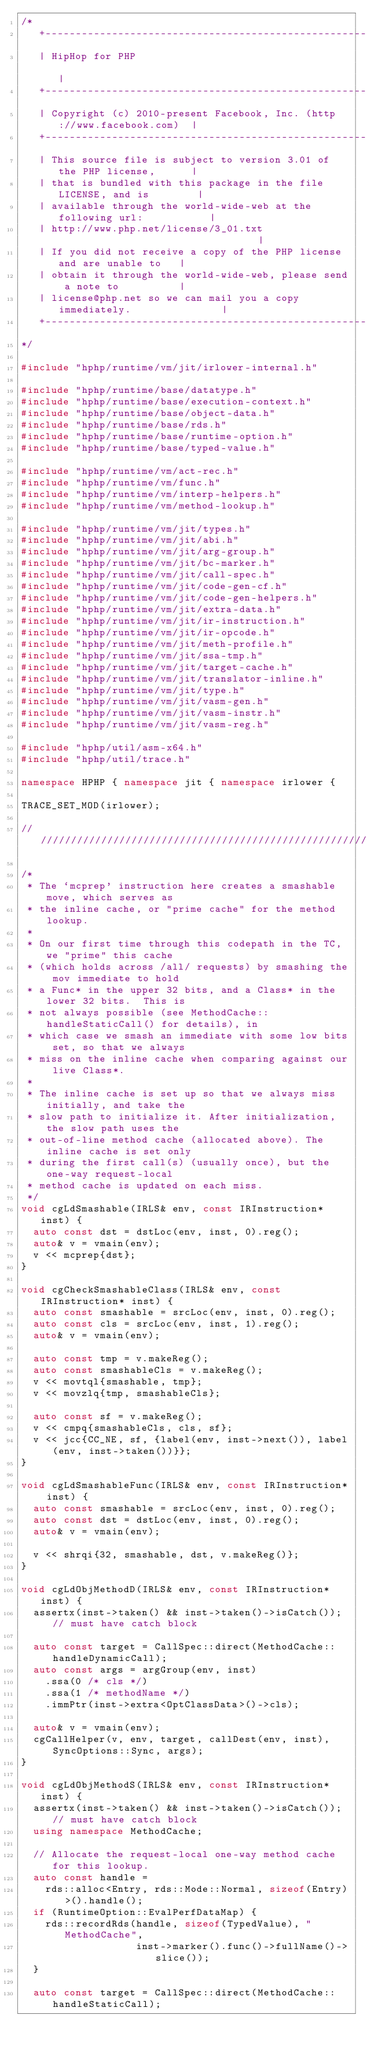<code> <loc_0><loc_0><loc_500><loc_500><_C++_>/*
   +----------------------------------------------------------------------+
   | HipHop for PHP                                                       |
   +----------------------------------------------------------------------+
   | Copyright (c) 2010-present Facebook, Inc. (http://www.facebook.com)  |
   +----------------------------------------------------------------------+
   | This source file is subject to version 3.01 of the PHP license,      |
   | that is bundled with this package in the file LICENSE, and is        |
   | available through the world-wide-web at the following url:           |
   | http://www.php.net/license/3_01.txt                                  |
   | If you did not receive a copy of the PHP license and are unable to   |
   | obtain it through the world-wide-web, please send a note to          |
   | license@php.net so we can mail you a copy immediately.               |
   +----------------------------------------------------------------------+
*/

#include "hphp/runtime/vm/jit/irlower-internal.h"

#include "hphp/runtime/base/datatype.h"
#include "hphp/runtime/base/execution-context.h"
#include "hphp/runtime/base/object-data.h"
#include "hphp/runtime/base/rds.h"
#include "hphp/runtime/base/runtime-option.h"
#include "hphp/runtime/base/typed-value.h"

#include "hphp/runtime/vm/act-rec.h"
#include "hphp/runtime/vm/func.h"
#include "hphp/runtime/vm/interp-helpers.h"
#include "hphp/runtime/vm/method-lookup.h"

#include "hphp/runtime/vm/jit/types.h"
#include "hphp/runtime/vm/jit/abi.h"
#include "hphp/runtime/vm/jit/arg-group.h"
#include "hphp/runtime/vm/jit/bc-marker.h"
#include "hphp/runtime/vm/jit/call-spec.h"
#include "hphp/runtime/vm/jit/code-gen-cf.h"
#include "hphp/runtime/vm/jit/code-gen-helpers.h"
#include "hphp/runtime/vm/jit/extra-data.h"
#include "hphp/runtime/vm/jit/ir-instruction.h"
#include "hphp/runtime/vm/jit/ir-opcode.h"
#include "hphp/runtime/vm/jit/meth-profile.h"
#include "hphp/runtime/vm/jit/ssa-tmp.h"
#include "hphp/runtime/vm/jit/target-cache.h"
#include "hphp/runtime/vm/jit/translator-inline.h"
#include "hphp/runtime/vm/jit/type.h"
#include "hphp/runtime/vm/jit/vasm-gen.h"
#include "hphp/runtime/vm/jit/vasm-instr.h"
#include "hphp/runtime/vm/jit/vasm-reg.h"

#include "hphp/util/asm-x64.h"
#include "hphp/util/trace.h"

namespace HPHP { namespace jit { namespace irlower {

TRACE_SET_MOD(irlower);

///////////////////////////////////////////////////////////////////////////////

/*
 * The `mcprep' instruction here creates a smashable move, which serves as
 * the inline cache, or "prime cache" for the method lookup.
 *
 * On our first time through this codepath in the TC, we "prime" this cache
 * (which holds across /all/ requests) by smashing the mov immediate to hold
 * a Func* in the upper 32 bits, and a Class* in the lower 32 bits.  This is
 * not always possible (see MethodCache::handleStaticCall() for details), in
 * which case we smash an immediate with some low bits set, so that we always
 * miss on the inline cache when comparing against our live Class*.
 *
 * The inline cache is set up so that we always miss initially, and take the
 * slow path to initialize it. After initialization, the slow path uses the
 * out-of-line method cache (allocated above). The inline cache is set only
 * during the first call(s) (usually once), but the one-way request-local
 * method cache is updated on each miss.
 */
void cgLdSmashable(IRLS& env, const IRInstruction* inst) {
  auto const dst = dstLoc(env, inst, 0).reg();
  auto& v = vmain(env);
  v << mcprep{dst};
}

void cgCheckSmashableClass(IRLS& env, const IRInstruction* inst) {
  auto const smashable = srcLoc(env, inst, 0).reg();
  auto const cls = srcLoc(env, inst, 1).reg();
  auto& v = vmain(env);

  auto const tmp = v.makeReg();
  auto const smashableCls = v.makeReg();
  v << movtql{smashable, tmp};
  v << movzlq{tmp, smashableCls};

  auto const sf = v.makeReg();
  v << cmpq{smashableCls, cls, sf};
  v << jcc{CC_NE, sf, {label(env, inst->next()), label(env, inst->taken())}};
}

void cgLdSmashableFunc(IRLS& env, const IRInstruction* inst) {
  auto const smashable = srcLoc(env, inst, 0).reg();
  auto const dst = dstLoc(env, inst, 0).reg();
  auto& v = vmain(env);

  v << shrqi{32, smashable, dst, v.makeReg()};
}

void cgLdObjMethodD(IRLS& env, const IRInstruction* inst) {
  assertx(inst->taken() && inst->taken()->isCatch()); // must have catch block

  auto const target = CallSpec::direct(MethodCache::handleDynamicCall);
  auto const args = argGroup(env, inst)
    .ssa(0 /* cls */)
    .ssa(1 /* methodName */)
    .immPtr(inst->extra<OptClassData>()->cls);

  auto& v = vmain(env);
  cgCallHelper(v, env, target, callDest(env, inst), SyncOptions::Sync, args);
}

void cgLdObjMethodS(IRLS& env, const IRInstruction* inst) {
  assertx(inst->taken() && inst->taken()->isCatch()); // must have catch block
  using namespace MethodCache;

  // Allocate the request-local one-way method cache for this lookup.
  auto const handle =
    rds::alloc<Entry, rds::Mode::Normal, sizeof(Entry)>().handle();
  if (RuntimeOption::EvalPerfDataMap) {
    rds::recordRds(handle, sizeof(TypedValue), "MethodCache",
                   inst->marker().func()->fullName()->slice());
  }

  auto const target = CallSpec::direct(MethodCache::handleStaticCall);</code> 